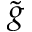Convert formula to latex. <formula><loc_0><loc_0><loc_500><loc_500>\tilde { g }</formula> 